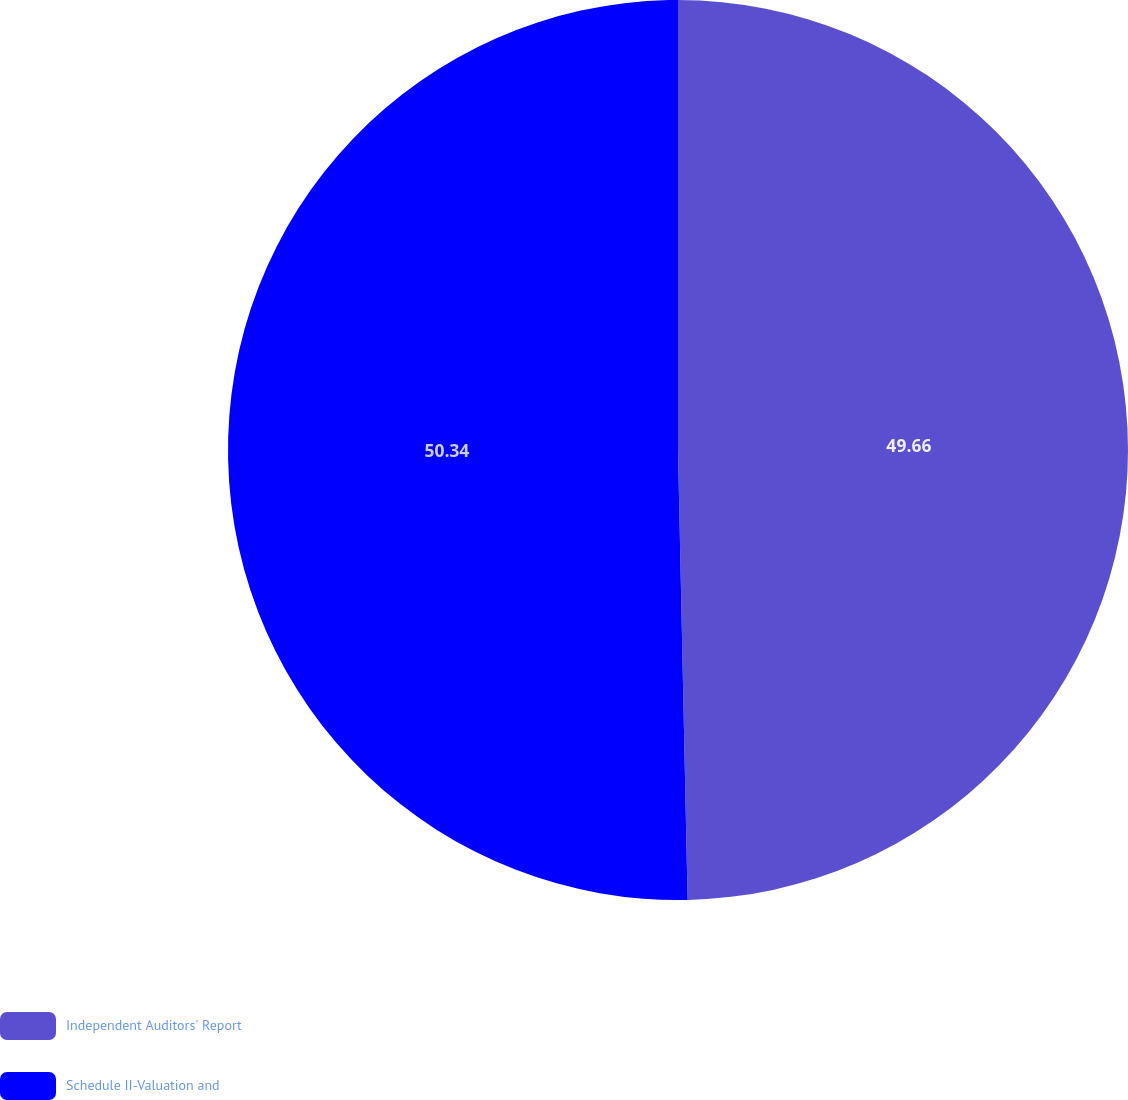Convert chart to OTSL. <chart><loc_0><loc_0><loc_500><loc_500><pie_chart><fcel>Independent Auditors' Report<fcel>Schedule II-Valuation and<nl><fcel>49.66%<fcel>50.34%<nl></chart> 